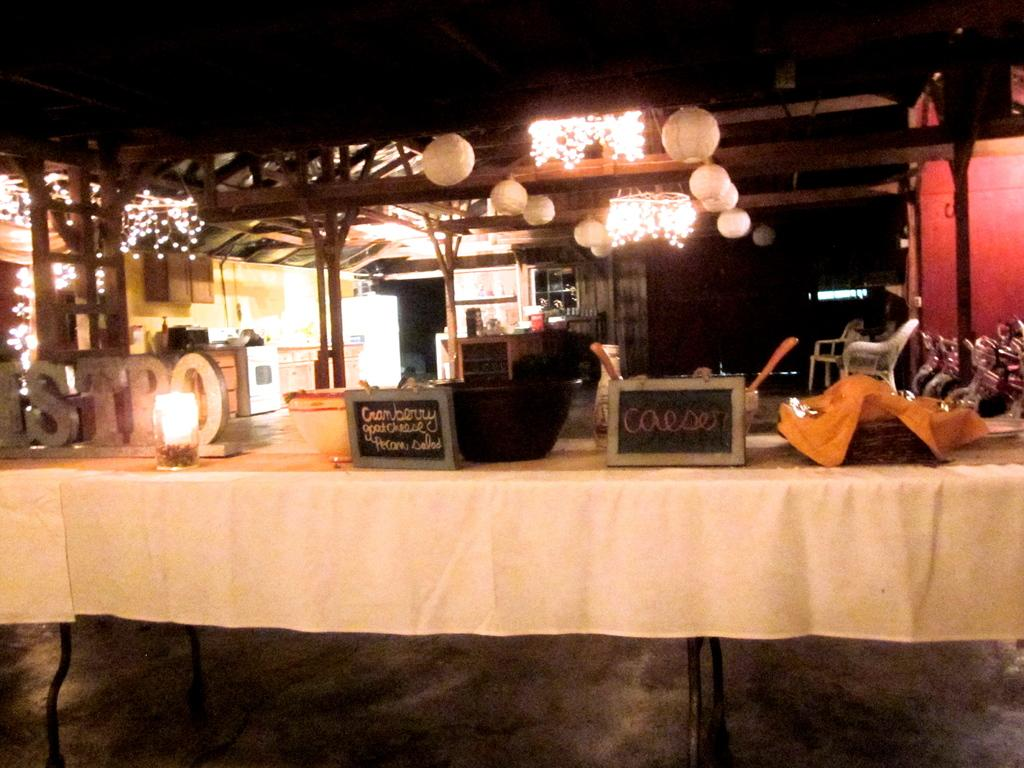What objects are on the table in the image? There are boxes on the table in the image. What can be seen on the roof in the image? There are lights on the roof in the image. What type of school is visible in the image? There is no school present in the image; it only features boxes on a table and lights on a roof. How does the fog affect the visibility in the image? There is no fog present in the image, so its effect on visibility cannot be determined. 